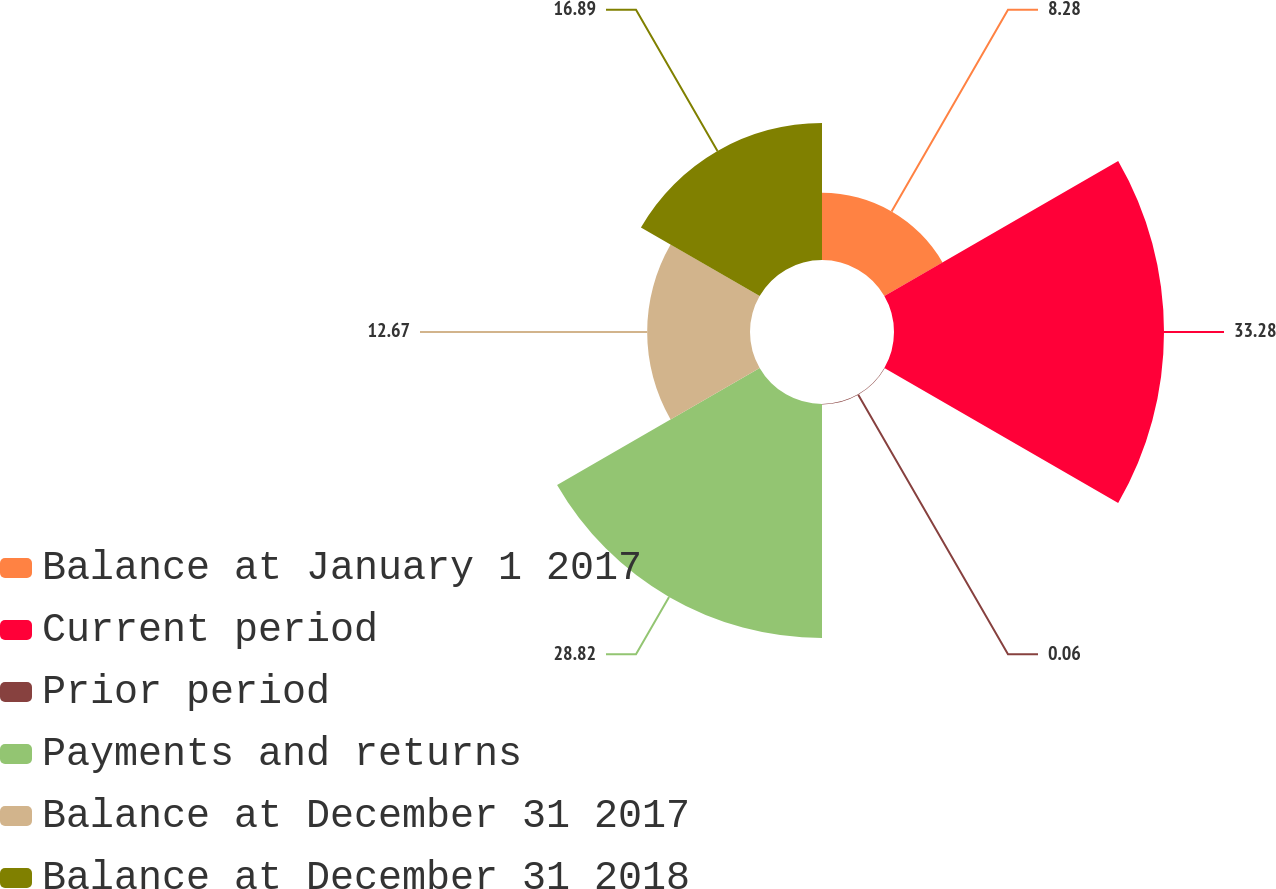<chart> <loc_0><loc_0><loc_500><loc_500><pie_chart><fcel>Balance at January 1 2017<fcel>Current period<fcel>Prior period<fcel>Payments and returns<fcel>Balance at December 31 2017<fcel>Balance at December 31 2018<nl><fcel>8.28%<fcel>33.27%<fcel>0.06%<fcel>28.82%<fcel>12.67%<fcel>16.89%<nl></chart> 